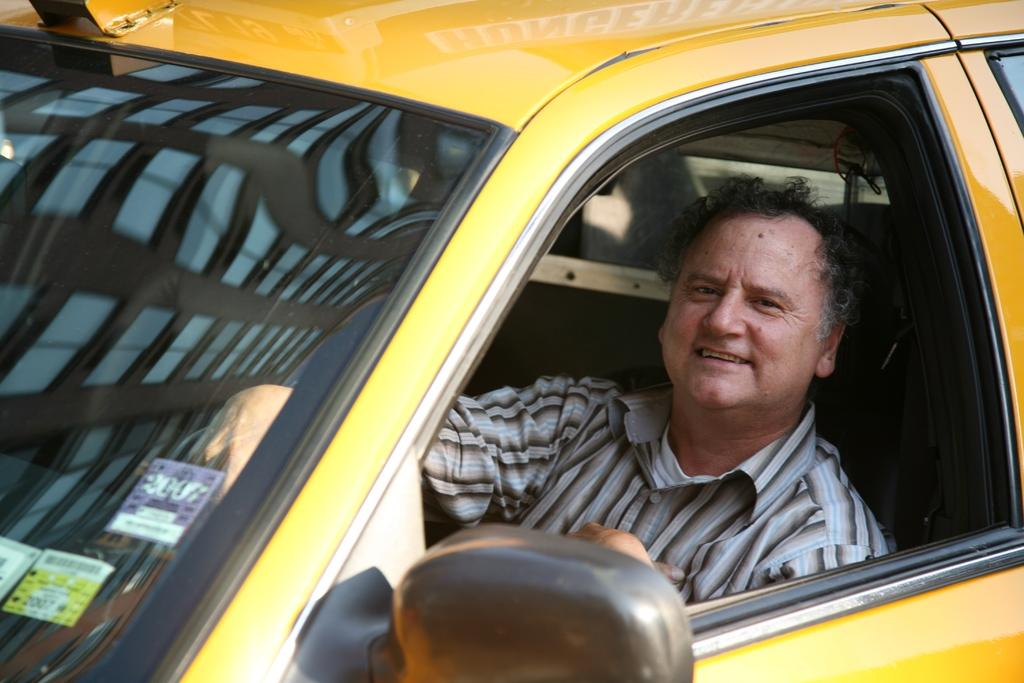What is the main subject of the picture? The main subject of the picture is a vehicle. Can you describe the person in the picture? There is a person sitting inside the vehicle. What type of badge is the person wearing in the picture? There is no information about a badge in the image, so it cannot be determined if the person is wearing one. 